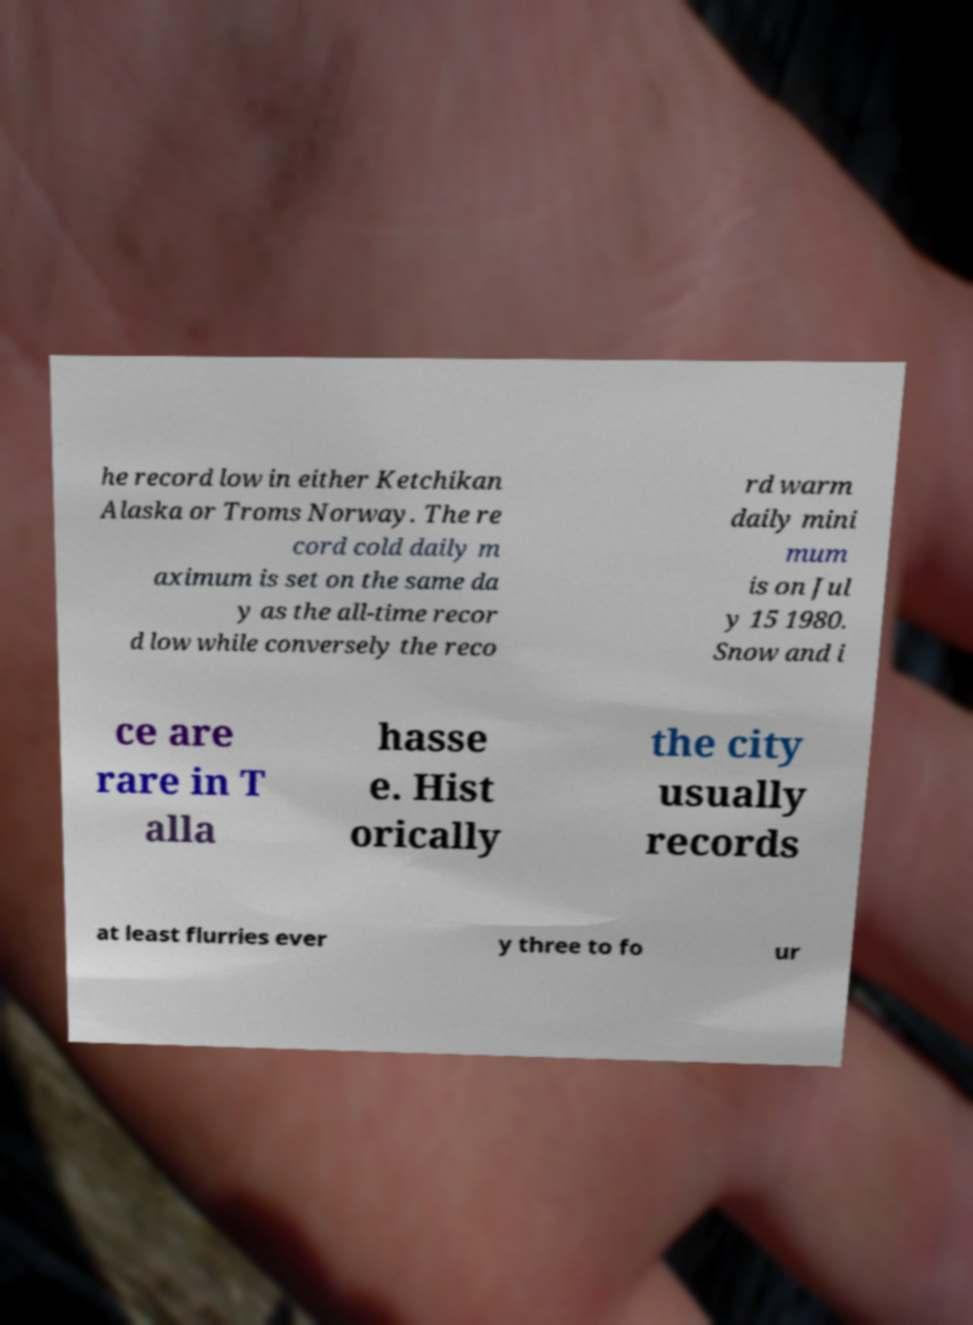Could you assist in decoding the text presented in this image and type it out clearly? he record low in either Ketchikan Alaska or Troms Norway. The re cord cold daily m aximum is set on the same da y as the all-time recor d low while conversely the reco rd warm daily mini mum is on Jul y 15 1980. Snow and i ce are rare in T alla hasse e. Hist orically the city usually records at least flurries ever y three to fo ur 